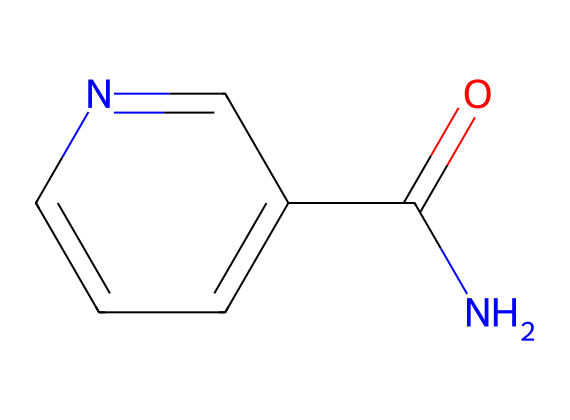What is the molecular formula of niacinamide? The molecular formula can be derived from the SMILES representation. Counting the atoms represented, we find 6 carbons, 6 hydrogens, 1 nitrogen, and 1 oxygen, which leads to the molecular formula C6H6N2O.
Answer: C6H6N2O How many rings are present in the structure? By analyzing the SMILES notation, we note that there is a cyclic part in the aromatic system. The 'c' indicates aromatic carbons, and there is only one ring present.
Answer: 1 What type of functional group is indicated by the 'NC(=O)' part? The 'NC(=O)' indicates an amide functional group due to the nitrogen single bonded to a carbon that is double bonded to an oxygen. This configuration is characteristic of amides.
Answer: amide Are there any geometric isomers possible for niacinamide? Geometric isomerism arises from restricted rotation around double bonds or specific ring structures. In this case, niacinamide does not have a double bond with substituents that allow for geometric isomers since it is primarily an aromatic compound with an amide.
Answer: No What is the hybridization of the nitrogen atom in niacinamide? To determine the hybridization of nitrogen in this structure, we observe that it is bonded to one carbon (the amide) and has one lone pair. This leads to sp2 hybridization due to the presence of one double bond and one single bond.
Answer: sp2 